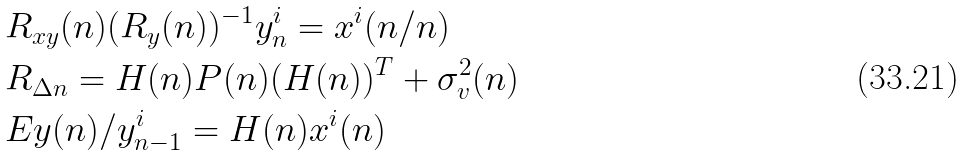<formula> <loc_0><loc_0><loc_500><loc_500>& R _ { x y } ( n ) ( R _ { y } ( n ) ) ^ { - 1 } y ^ { i } _ { n } = x ^ { i } ( n / n ) \\ & R _ { \Delta n } = H ( n ) P ( n ) ( H ( n ) ) ^ { T } + \sigma _ { v } ^ { 2 } ( n ) \\ & E y ( n ) / y ^ { i } _ { n - 1 } = H ( n ) x ^ { i } ( n )</formula> 